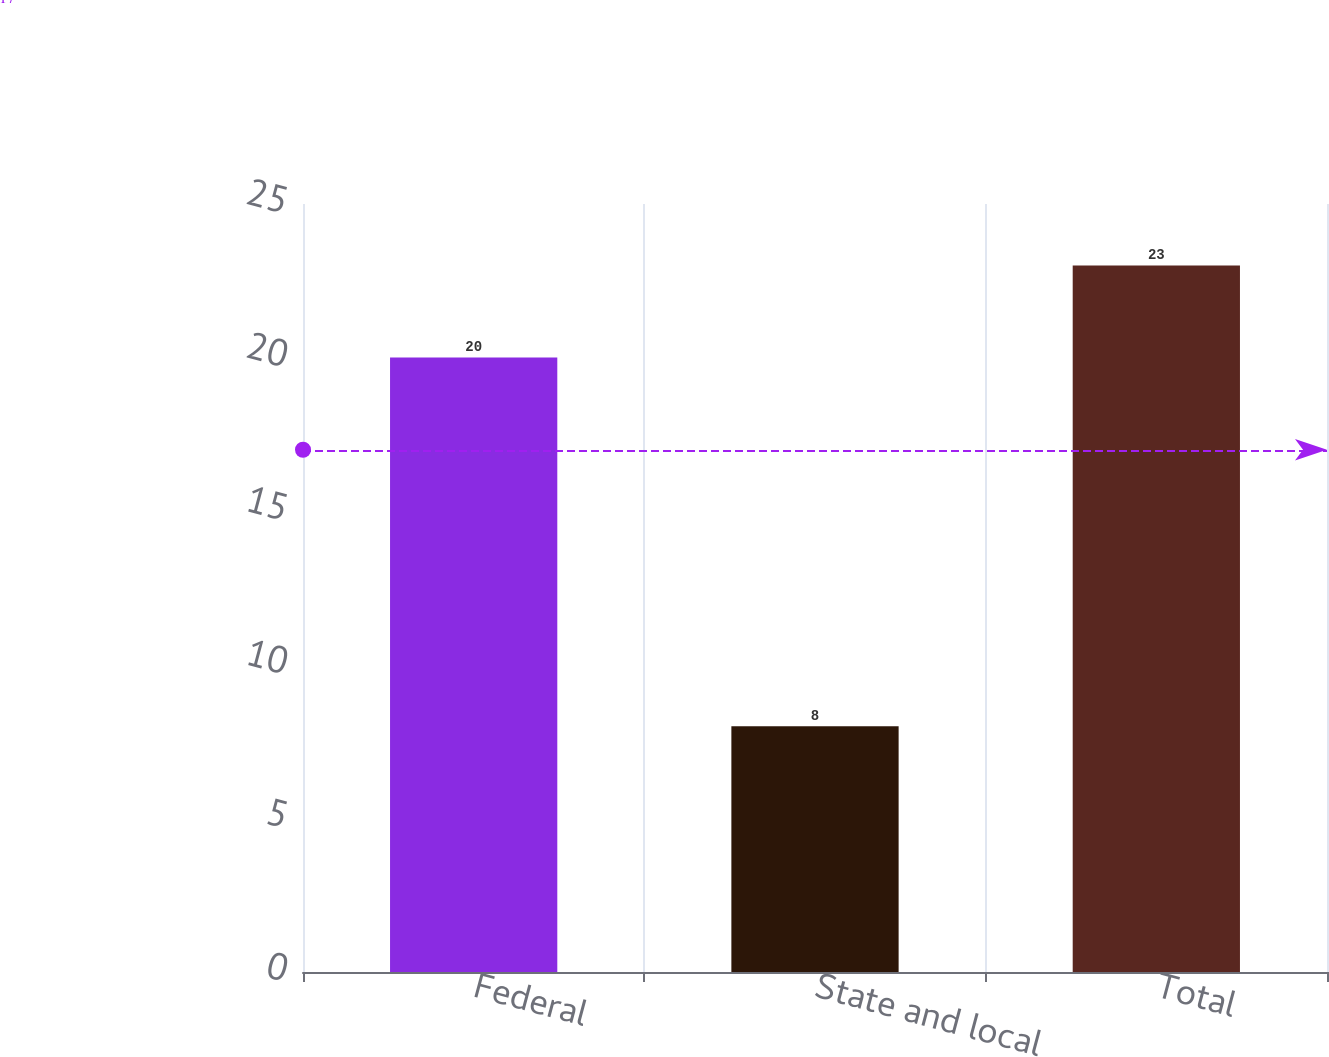Convert chart to OTSL. <chart><loc_0><loc_0><loc_500><loc_500><bar_chart><fcel>Federal<fcel>State and local<fcel>Total<nl><fcel>20<fcel>8<fcel>23<nl></chart> 